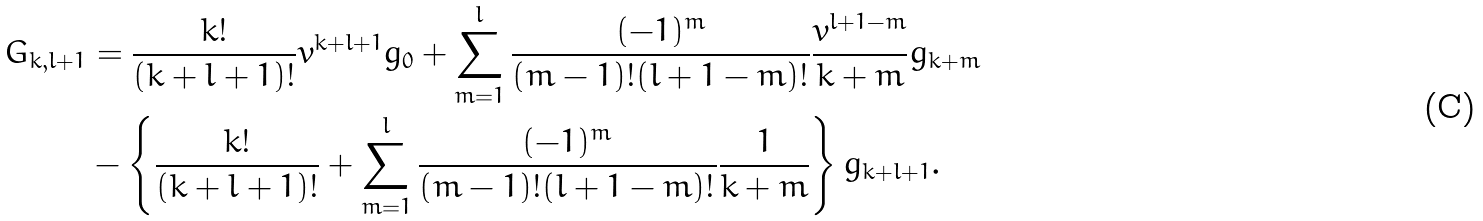Convert formula to latex. <formula><loc_0><loc_0><loc_500><loc_500>G _ { k , l + 1 } & = \frac { k ! } { ( k + l + 1 ) ! } v ^ { k + l + 1 } g _ { 0 } + \sum _ { m = 1 } ^ { l } \frac { ( - 1 ) ^ { m } } { ( m - 1 ) ! ( l + 1 - m ) ! } \frac { v ^ { l + 1 - m } } { k + m } g _ { k + m } \\ & - \left \{ \frac { k ! } { ( k + l + 1 ) ! } + \sum _ { m = 1 } ^ { l } \frac { ( - 1 ) ^ { m } } { ( m - 1 ) ! ( l + 1 - m ) ! } \frac { 1 } { k + m } \right \} g _ { k + l + 1 } .</formula> 